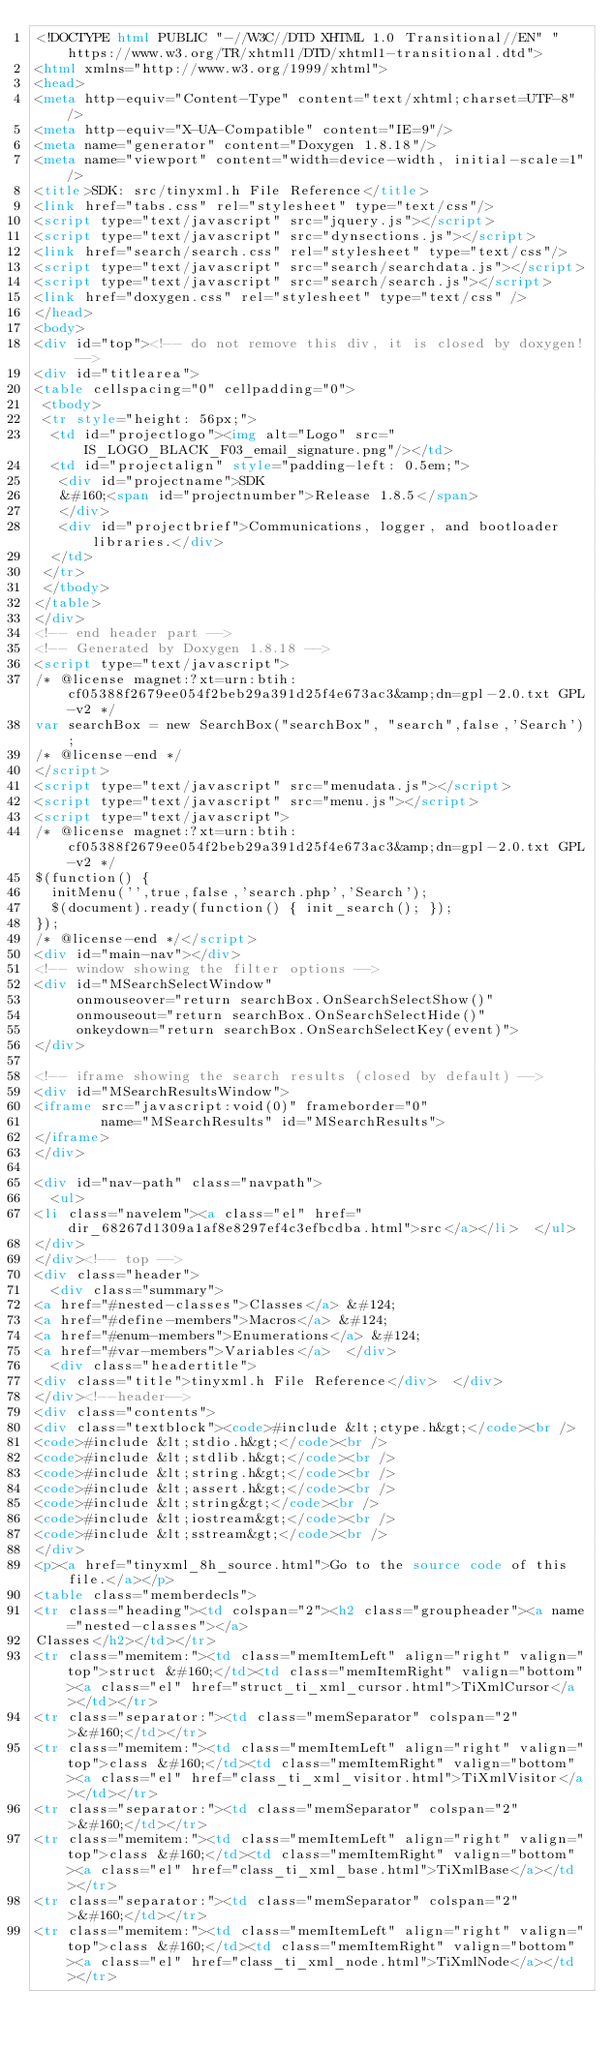Convert code to text. <code><loc_0><loc_0><loc_500><loc_500><_HTML_><!DOCTYPE html PUBLIC "-//W3C//DTD XHTML 1.0 Transitional//EN" "https://www.w3.org/TR/xhtml1/DTD/xhtml1-transitional.dtd">
<html xmlns="http://www.w3.org/1999/xhtml">
<head>
<meta http-equiv="Content-Type" content="text/xhtml;charset=UTF-8"/>
<meta http-equiv="X-UA-Compatible" content="IE=9"/>
<meta name="generator" content="Doxygen 1.8.18"/>
<meta name="viewport" content="width=device-width, initial-scale=1"/>
<title>SDK: src/tinyxml.h File Reference</title>
<link href="tabs.css" rel="stylesheet" type="text/css"/>
<script type="text/javascript" src="jquery.js"></script>
<script type="text/javascript" src="dynsections.js"></script>
<link href="search/search.css" rel="stylesheet" type="text/css"/>
<script type="text/javascript" src="search/searchdata.js"></script>
<script type="text/javascript" src="search/search.js"></script>
<link href="doxygen.css" rel="stylesheet" type="text/css" />
</head>
<body>
<div id="top"><!-- do not remove this div, it is closed by doxygen! -->
<div id="titlearea">
<table cellspacing="0" cellpadding="0">
 <tbody>
 <tr style="height: 56px;">
  <td id="projectlogo"><img alt="Logo" src="IS_LOGO_BLACK_F03_email_signature.png"/></td>
  <td id="projectalign" style="padding-left: 0.5em;">
   <div id="projectname">SDK
   &#160;<span id="projectnumber">Release 1.8.5</span>
   </div>
   <div id="projectbrief">Communications, logger, and bootloader libraries.</div>
  </td>
 </tr>
 </tbody>
</table>
</div>
<!-- end header part -->
<!-- Generated by Doxygen 1.8.18 -->
<script type="text/javascript">
/* @license magnet:?xt=urn:btih:cf05388f2679ee054f2beb29a391d25f4e673ac3&amp;dn=gpl-2.0.txt GPL-v2 */
var searchBox = new SearchBox("searchBox", "search",false,'Search');
/* @license-end */
</script>
<script type="text/javascript" src="menudata.js"></script>
<script type="text/javascript" src="menu.js"></script>
<script type="text/javascript">
/* @license magnet:?xt=urn:btih:cf05388f2679ee054f2beb29a391d25f4e673ac3&amp;dn=gpl-2.0.txt GPL-v2 */
$(function() {
  initMenu('',true,false,'search.php','Search');
  $(document).ready(function() { init_search(); });
});
/* @license-end */</script>
<div id="main-nav"></div>
<!-- window showing the filter options -->
<div id="MSearchSelectWindow"
     onmouseover="return searchBox.OnSearchSelectShow()"
     onmouseout="return searchBox.OnSearchSelectHide()"
     onkeydown="return searchBox.OnSearchSelectKey(event)">
</div>

<!-- iframe showing the search results (closed by default) -->
<div id="MSearchResultsWindow">
<iframe src="javascript:void(0)" frameborder="0" 
        name="MSearchResults" id="MSearchResults">
</iframe>
</div>

<div id="nav-path" class="navpath">
  <ul>
<li class="navelem"><a class="el" href="dir_68267d1309a1af8e8297ef4c3efbcdba.html">src</a></li>  </ul>
</div>
</div><!-- top -->
<div class="header">
  <div class="summary">
<a href="#nested-classes">Classes</a> &#124;
<a href="#define-members">Macros</a> &#124;
<a href="#enum-members">Enumerations</a> &#124;
<a href="#var-members">Variables</a>  </div>
  <div class="headertitle">
<div class="title">tinyxml.h File Reference</div>  </div>
</div><!--header-->
<div class="contents">
<div class="textblock"><code>#include &lt;ctype.h&gt;</code><br />
<code>#include &lt;stdio.h&gt;</code><br />
<code>#include &lt;stdlib.h&gt;</code><br />
<code>#include &lt;string.h&gt;</code><br />
<code>#include &lt;assert.h&gt;</code><br />
<code>#include &lt;string&gt;</code><br />
<code>#include &lt;iostream&gt;</code><br />
<code>#include &lt;sstream&gt;</code><br />
</div>
<p><a href="tinyxml_8h_source.html">Go to the source code of this file.</a></p>
<table class="memberdecls">
<tr class="heading"><td colspan="2"><h2 class="groupheader"><a name="nested-classes"></a>
Classes</h2></td></tr>
<tr class="memitem:"><td class="memItemLeft" align="right" valign="top">struct &#160;</td><td class="memItemRight" valign="bottom"><a class="el" href="struct_ti_xml_cursor.html">TiXmlCursor</a></td></tr>
<tr class="separator:"><td class="memSeparator" colspan="2">&#160;</td></tr>
<tr class="memitem:"><td class="memItemLeft" align="right" valign="top">class &#160;</td><td class="memItemRight" valign="bottom"><a class="el" href="class_ti_xml_visitor.html">TiXmlVisitor</a></td></tr>
<tr class="separator:"><td class="memSeparator" colspan="2">&#160;</td></tr>
<tr class="memitem:"><td class="memItemLeft" align="right" valign="top">class &#160;</td><td class="memItemRight" valign="bottom"><a class="el" href="class_ti_xml_base.html">TiXmlBase</a></td></tr>
<tr class="separator:"><td class="memSeparator" colspan="2">&#160;</td></tr>
<tr class="memitem:"><td class="memItemLeft" align="right" valign="top">class &#160;</td><td class="memItemRight" valign="bottom"><a class="el" href="class_ti_xml_node.html">TiXmlNode</a></td></tr></code> 